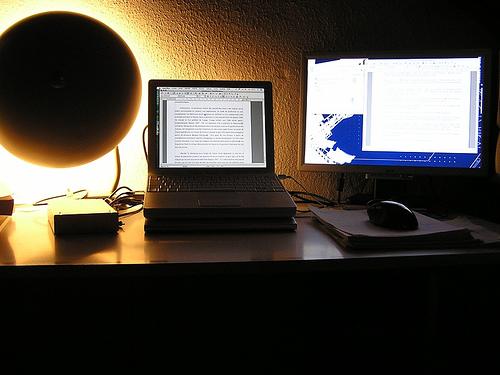Is somebody working with these computers?
Quick response, please. No. Is the computer on the right an apple?
Write a very short answer. No. How many laptops are there?
Write a very short answer. 1. 